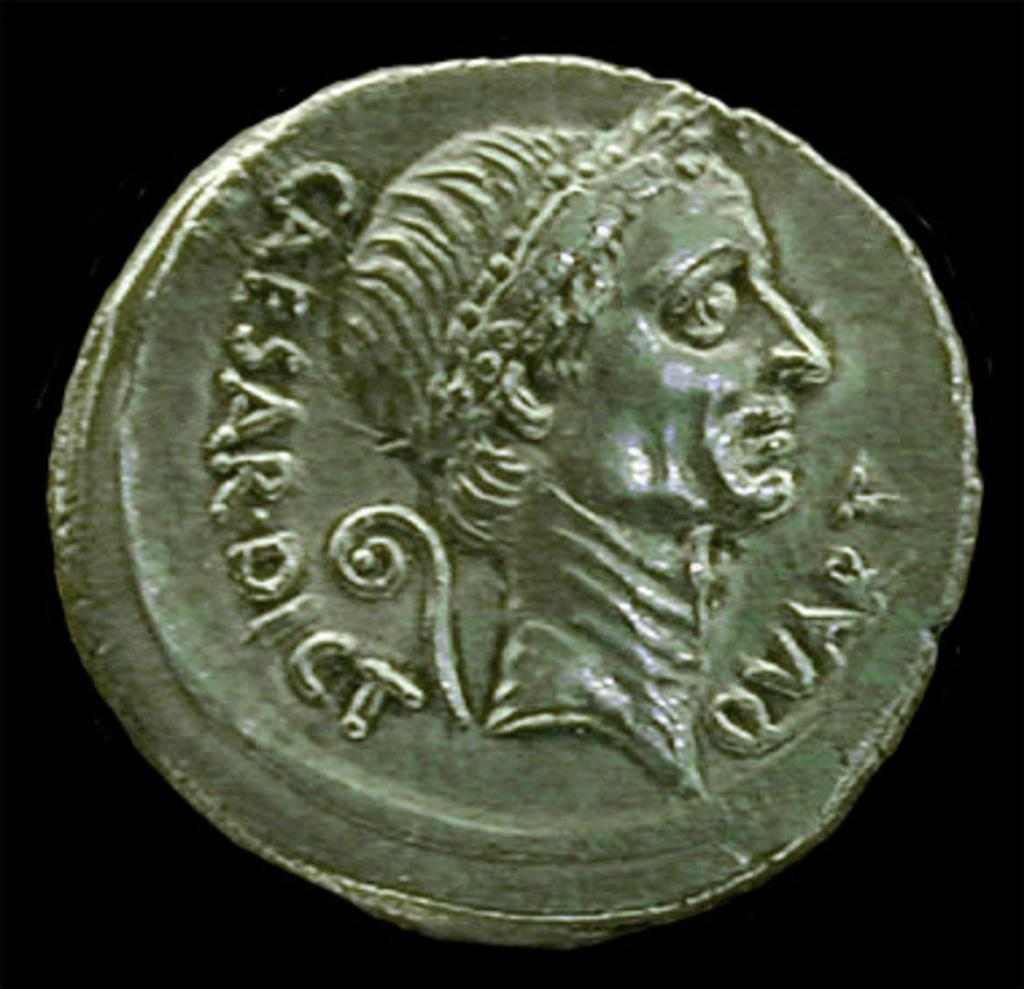Provide a one-sentence caption for the provided image. an old roman coin with Caesar Dict Quart on it. 